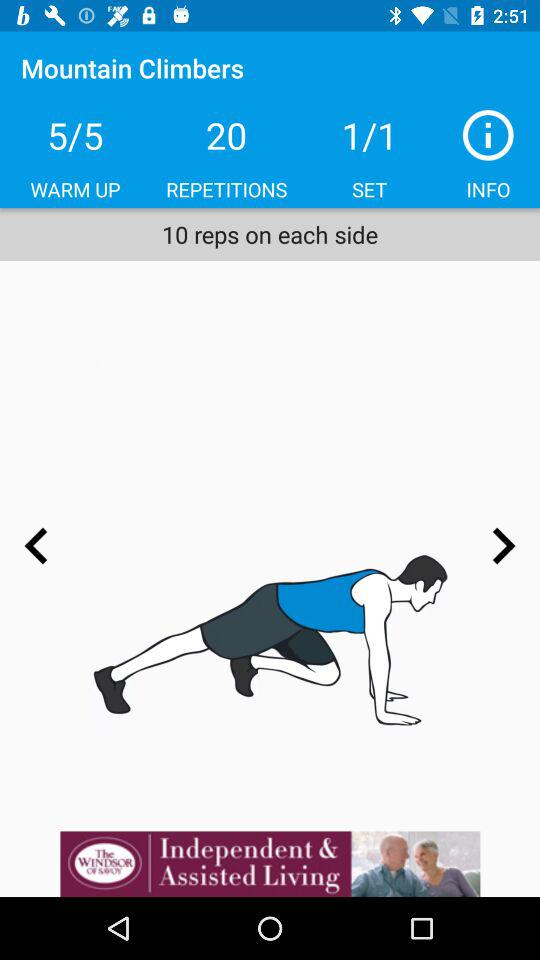How many sets are there for the exercise?
Answer the question using a single word or phrase. 1 